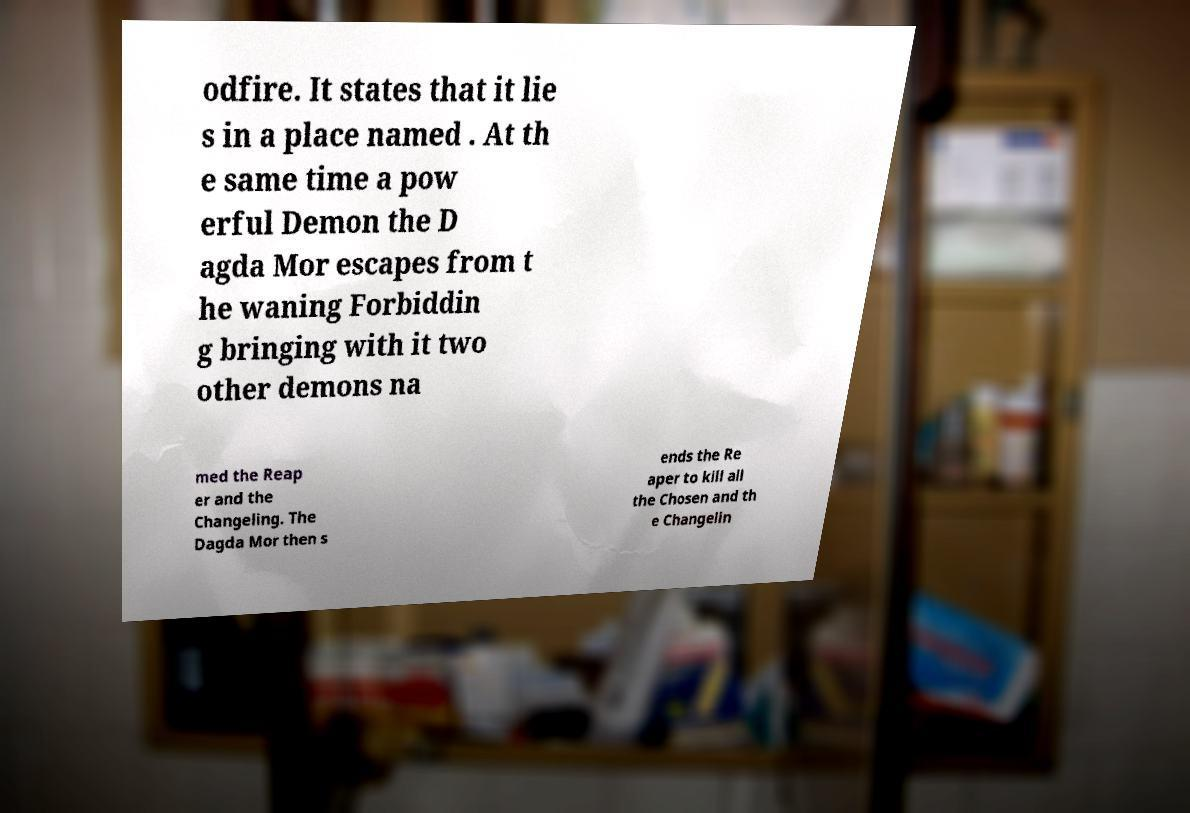Can you read and provide the text displayed in the image?This photo seems to have some interesting text. Can you extract and type it out for me? odfire. It states that it lie s in a place named . At th e same time a pow erful Demon the D agda Mor escapes from t he waning Forbiddin g bringing with it two other demons na med the Reap er and the Changeling. The Dagda Mor then s ends the Re aper to kill all the Chosen and th e Changelin 